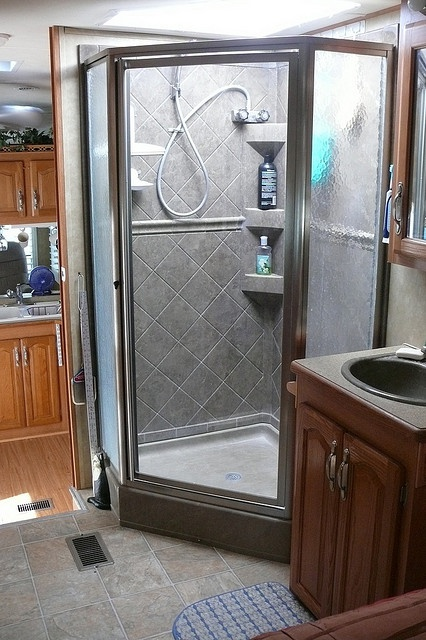Describe the objects in this image and their specific colors. I can see sink in gray, black, darkgray, and lightgray tones, bottle in gray, black, and darkgray tones, bottle in gray, lightblue, and darkgray tones, and sink in gray, darkgray, and lightgray tones in this image. 